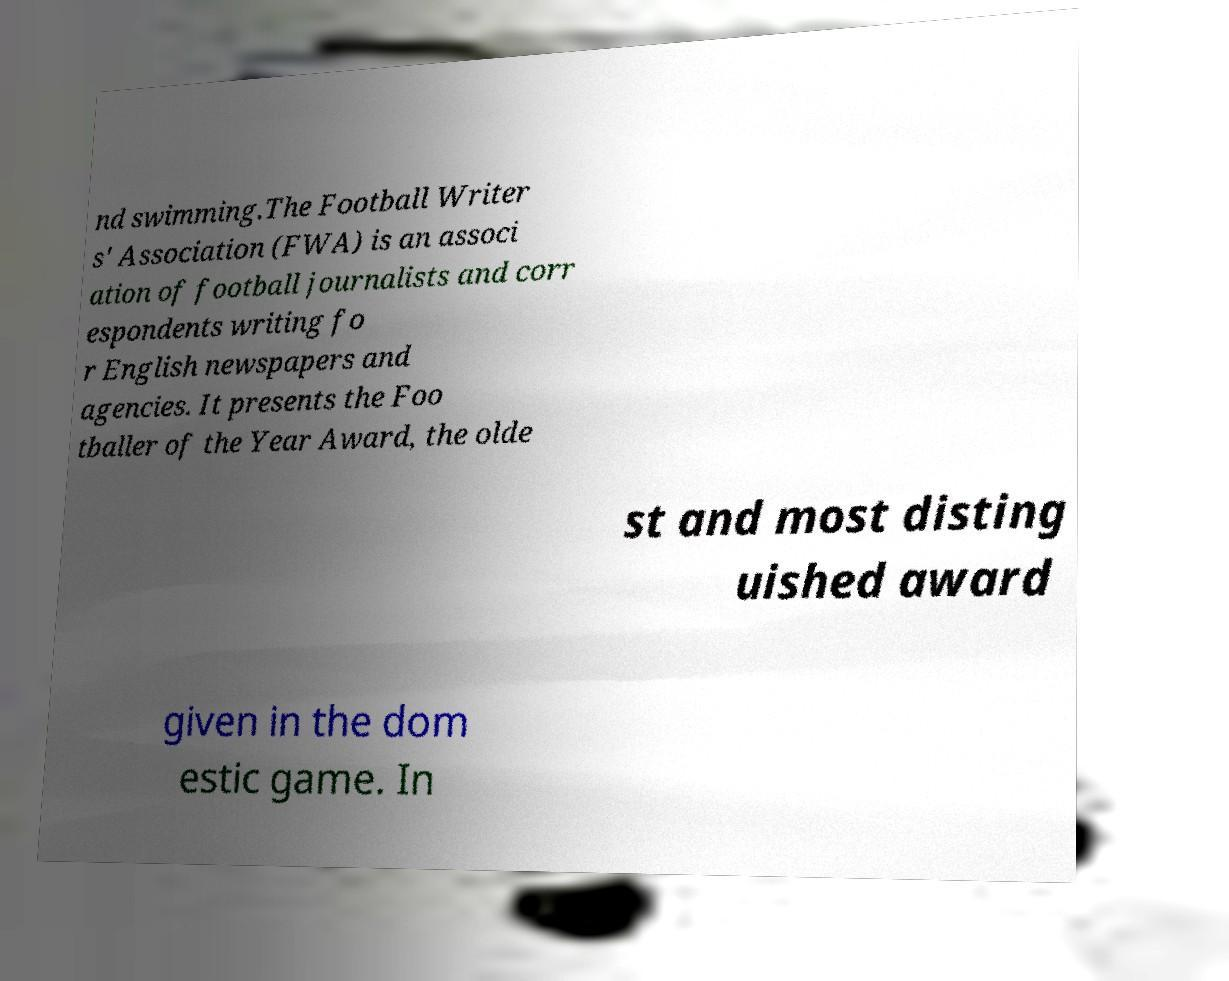Could you extract and type out the text from this image? nd swimming.The Football Writer s' Association (FWA) is an associ ation of football journalists and corr espondents writing fo r English newspapers and agencies. It presents the Foo tballer of the Year Award, the olde st and most disting uished award given in the dom estic game. In 